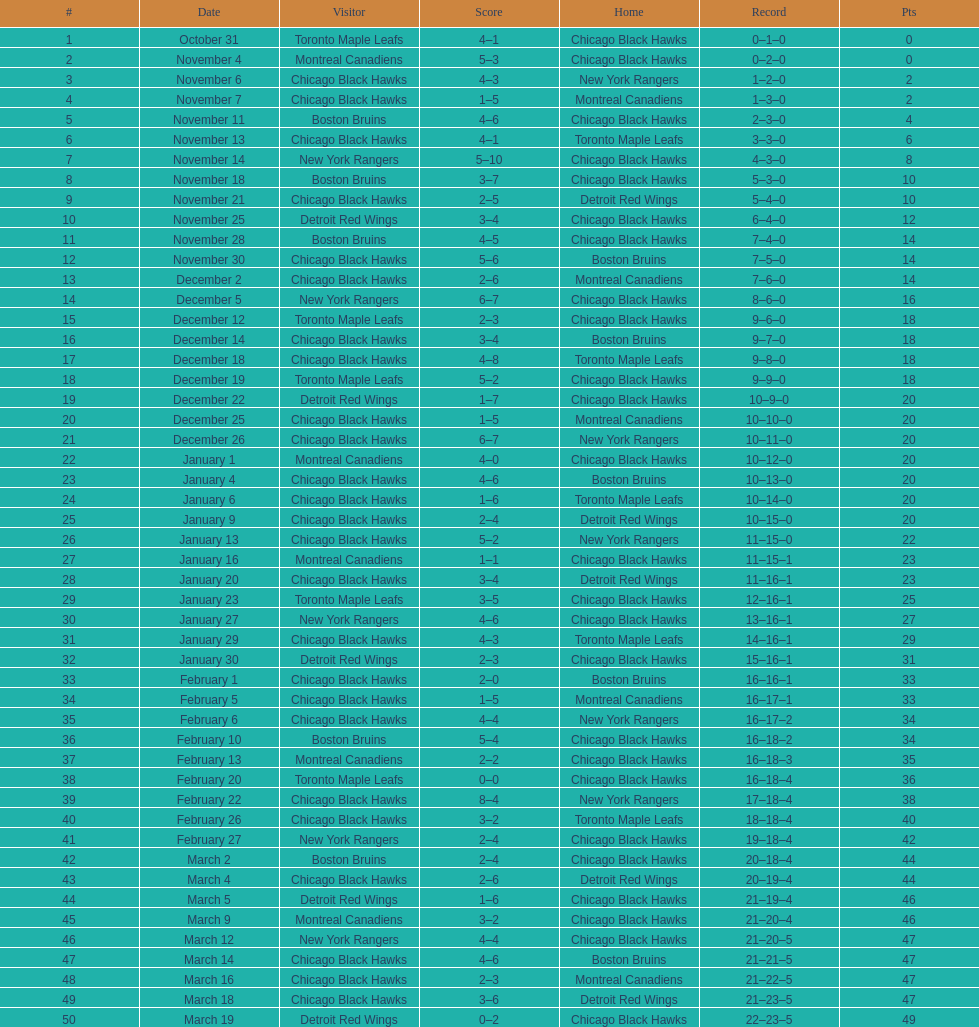Which team was the earliest one the black hawks got beaten by? Toronto Maple Leafs. 